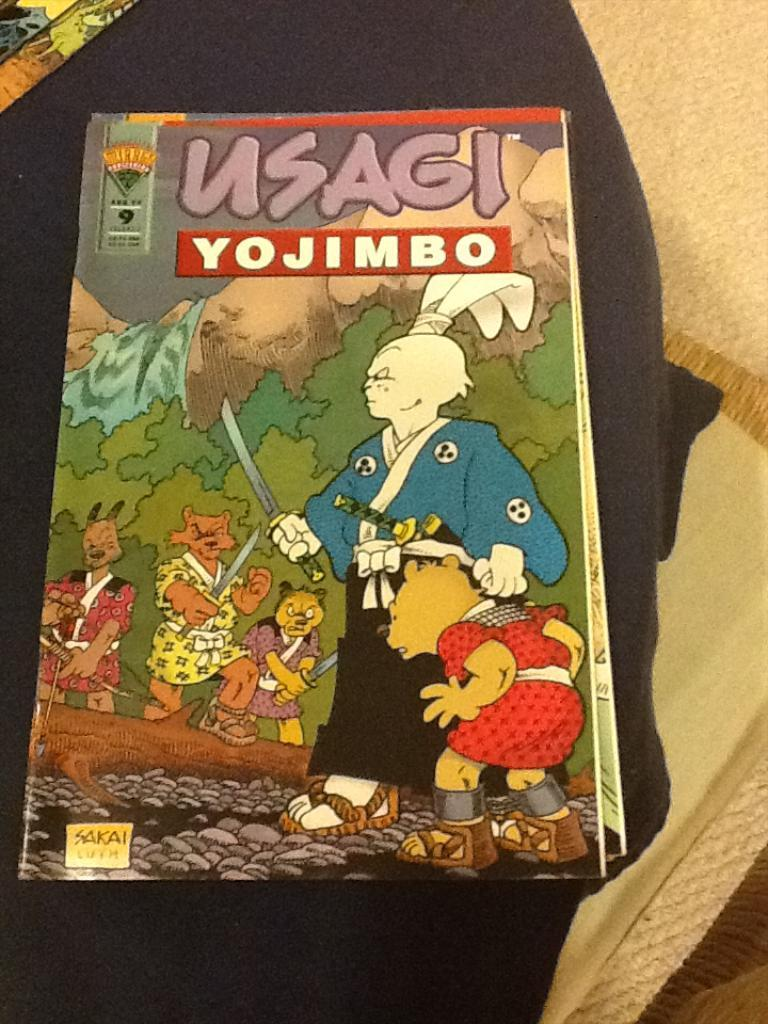<image>
Offer a succinct explanation of the picture presented. A comic book on a lap with the title of Usagi Yojimbo. 